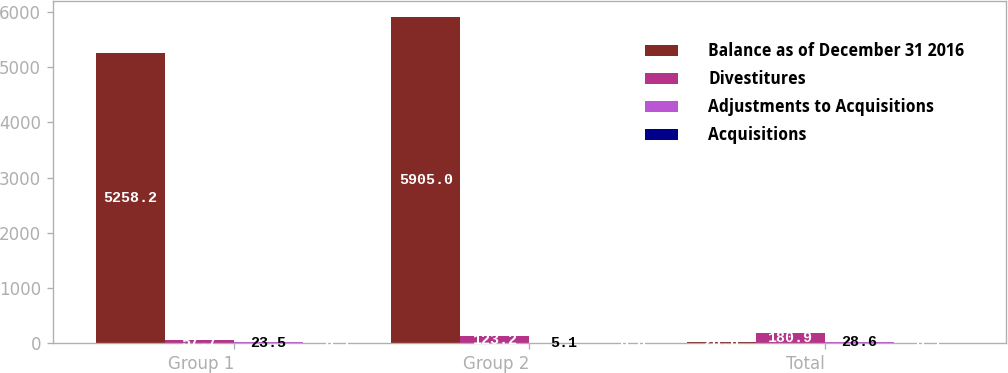Convert chart to OTSL. <chart><loc_0><loc_0><loc_500><loc_500><stacked_bar_chart><ecel><fcel>Group 1<fcel>Group 2<fcel>Total<nl><fcel>Balance as of December 31 2016<fcel>5258.2<fcel>5905<fcel>28.6<nl><fcel>Divestitures<fcel>57.7<fcel>123.2<fcel>180.9<nl><fcel>Adjustments to Acquisitions<fcel>23.5<fcel>5.1<fcel>28.6<nl><fcel>Acquisitions<fcel>6.1<fcel>6<fcel>0.1<nl></chart> 